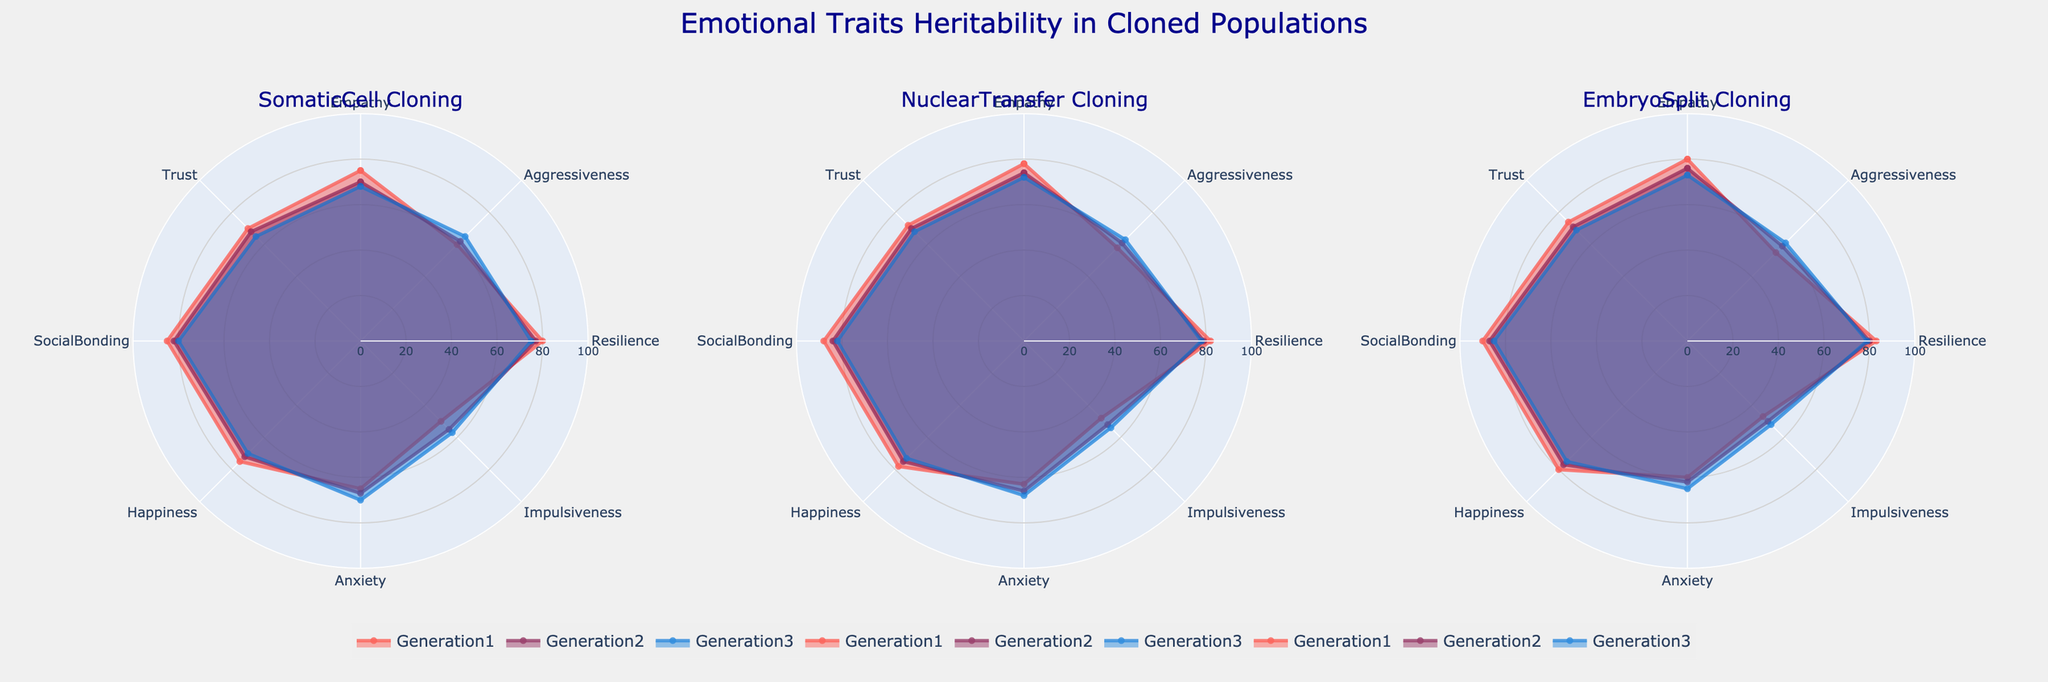Which cloning technique shows the highest empathy in Generation 1? To find this, look at the empathy value for Generation 1 across all three cloning techniques. Compare the values 75 (Somatic Cell), 78 (Nuclear Transfer), and 80 (Embryo Split) and select the highest one.
Answer: Embryo Split How does the anxiety level change from Generation 1 to Generation 3 for Nuclear Transfer clones? To determine this, observe the anxiety levels in Generations 1, 2, and 3 for Nuclear Transfer. The values are 63, 66, and 68 respectively. Note the increase from 63 to 68.
Answer: Increases Which cloning technique exhibited the lowest level of impulsiveness in Generation 3? Examine the impulsiveness levels in Generation 3 across the three techniques. The values are 57 (Somatic Cell), 54 (Nuclear Transfer), and 52 (Embryo Split).
Answer: Embryo Split Between Empathy and Social Bonding, which emotional trait has a higher value in Generation 2 for Somatic Cell Cloning? Look at the Generation 2 value for Empathy (70) and Social Bonding (82) in Somatic Cell Cloning. Compare these values.
Answer: Social Bonding By examining the radar charts, determine which emotional trait shows the most consistency across all three generations for Embryo Split clones. Look at the values for each emotional trait in generations 1, 2, and 3 for Embryo Split clones and identify the trait with the least variance. Trust has values 74, 71, and 69, showing the most consistency.
Answer: Trust What is the generalized trend of happiness in Embryo Split generations from 1 to 3? Check the values of happiness in Embryo Split technique across Generations 1, 2, and 3, which are 80, 77, and 75. Note the decreasing pattern.
Answer: Decreasing What are the trust values for Generation 3 clones across all techniques? Look at the Generation 3 row for Trust under each cloning technique: Somatic Cell, Nuclear Transfer, and Embryo Split. The values are 65, 68, and 69 respectively.
Answer: 65, 68, 69 Which cloning technique demonstrates the greatest resilience in Generation 2? Compare the resilience values in Generation 2 across all techniques: 77 (Somatic Cell), 79 (Nuclear Transfer), and 80 (Embryo Split). The highest value is 80.
Answer: Embryo Split How does Generation 1's happiness for Somatic Cell Cloning compare to Generation 3's happiness for the same technique? Compare the happiness values of 75 in Generation 1 and 70 in Generation 3 for Somatic Cell Cloning to see the trend.
Answer: Decreases What is the average resilience score for all generations in Nuclear Transfer Cloning? Calculate (82 + 79 + 78) / 3. Add the values for each generation (82, 79, 78) and then divide by the number of generations (3). The average is (239 / 3).
Answer: 79.67 